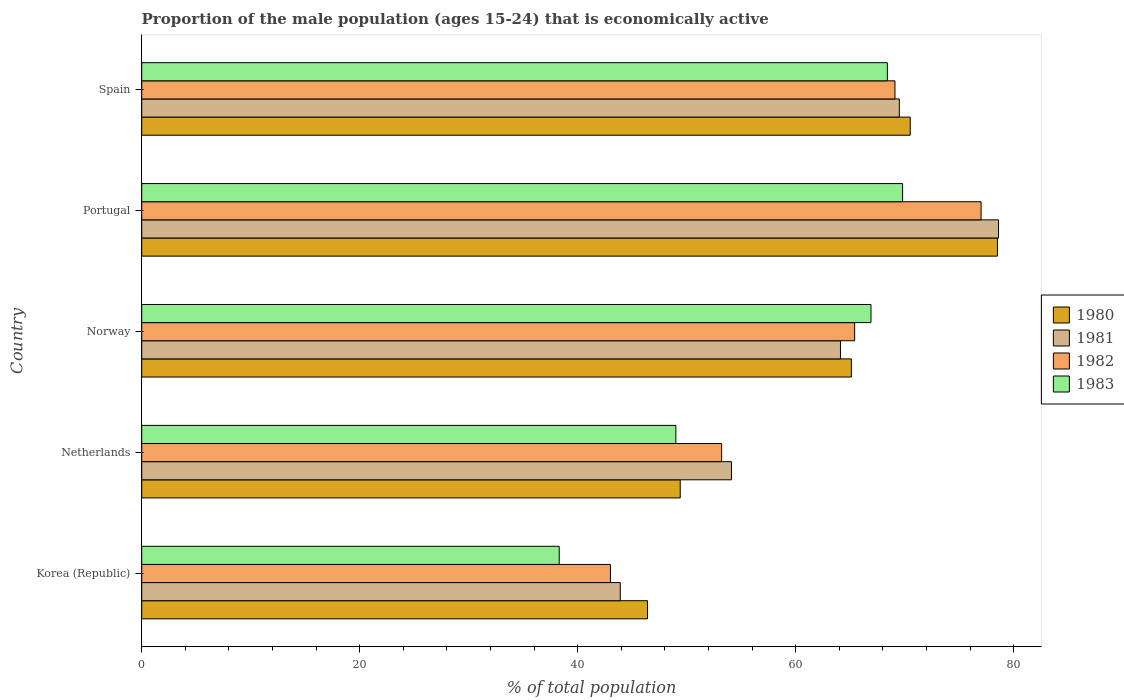How many groups of bars are there?
Give a very brief answer. 5. Are the number of bars on each tick of the Y-axis equal?
Give a very brief answer. Yes. How many bars are there on the 2nd tick from the top?
Your response must be concise. 4. In how many cases, is the number of bars for a given country not equal to the number of legend labels?
Provide a short and direct response. 0. What is the proportion of the male population that is economically active in 1983 in Norway?
Give a very brief answer. 66.9. Across all countries, what is the maximum proportion of the male population that is economically active in 1983?
Give a very brief answer. 69.8. In which country was the proportion of the male population that is economically active in 1982 minimum?
Offer a very short reply. Korea (Republic). What is the total proportion of the male population that is economically active in 1982 in the graph?
Your response must be concise. 307.7. What is the difference between the proportion of the male population that is economically active in 1982 in Portugal and that in Spain?
Keep it short and to the point. 7.9. What is the average proportion of the male population that is economically active in 1983 per country?
Make the answer very short. 58.48. What is the difference between the proportion of the male population that is economically active in 1983 and proportion of the male population that is economically active in 1982 in Korea (Republic)?
Your answer should be compact. -4.7. What is the ratio of the proportion of the male population that is economically active in 1980 in Netherlands to that in Norway?
Offer a terse response. 0.76. Is the difference between the proportion of the male population that is economically active in 1983 in Norway and Spain greater than the difference between the proportion of the male population that is economically active in 1982 in Norway and Spain?
Ensure brevity in your answer.  Yes. What is the difference between the highest and the second highest proportion of the male population that is economically active in 1983?
Your answer should be very brief. 1.4. What is the difference between the highest and the lowest proportion of the male population that is economically active in 1982?
Offer a very short reply. 34. In how many countries, is the proportion of the male population that is economically active in 1982 greater than the average proportion of the male population that is economically active in 1982 taken over all countries?
Offer a terse response. 3. Is the sum of the proportion of the male population that is economically active in 1980 in Korea (Republic) and Portugal greater than the maximum proportion of the male population that is economically active in 1983 across all countries?
Keep it short and to the point. Yes. Is it the case that in every country, the sum of the proportion of the male population that is economically active in 1980 and proportion of the male population that is economically active in 1982 is greater than the sum of proportion of the male population that is economically active in 1983 and proportion of the male population that is economically active in 1981?
Offer a terse response. No. What does the 3rd bar from the bottom in Spain represents?
Provide a short and direct response. 1982. Is it the case that in every country, the sum of the proportion of the male population that is economically active in 1983 and proportion of the male population that is economically active in 1982 is greater than the proportion of the male population that is economically active in 1980?
Ensure brevity in your answer.  Yes. Are all the bars in the graph horizontal?
Ensure brevity in your answer.  Yes. How many countries are there in the graph?
Provide a succinct answer. 5. What is the difference between two consecutive major ticks on the X-axis?
Your answer should be very brief. 20. Are the values on the major ticks of X-axis written in scientific E-notation?
Provide a short and direct response. No. Does the graph contain any zero values?
Give a very brief answer. No. Does the graph contain grids?
Give a very brief answer. No. How are the legend labels stacked?
Your answer should be compact. Vertical. What is the title of the graph?
Provide a short and direct response. Proportion of the male population (ages 15-24) that is economically active. What is the label or title of the X-axis?
Make the answer very short. % of total population. What is the % of total population in 1980 in Korea (Republic)?
Your answer should be compact. 46.4. What is the % of total population of 1981 in Korea (Republic)?
Offer a very short reply. 43.9. What is the % of total population of 1982 in Korea (Republic)?
Offer a terse response. 43. What is the % of total population in 1983 in Korea (Republic)?
Keep it short and to the point. 38.3. What is the % of total population in 1980 in Netherlands?
Your answer should be compact. 49.4. What is the % of total population of 1981 in Netherlands?
Make the answer very short. 54.1. What is the % of total population in 1982 in Netherlands?
Ensure brevity in your answer.  53.2. What is the % of total population of 1983 in Netherlands?
Your response must be concise. 49. What is the % of total population in 1980 in Norway?
Ensure brevity in your answer.  65.1. What is the % of total population of 1981 in Norway?
Ensure brevity in your answer.  64.1. What is the % of total population in 1982 in Norway?
Make the answer very short. 65.4. What is the % of total population in 1983 in Norway?
Provide a short and direct response. 66.9. What is the % of total population of 1980 in Portugal?
Offer a terse response. 78.5. What is the % of total population of 1981 in Portugal?
Give a very brief answer. 78.6. What is the % of total population of 1983 in Portugal?
Ensure brevity in your answer.  69.8. What is the % of total population in 1980 in Spain?
Your response must be concise. 70.5. What is the % of total population in 1981 in Spain?
Keep it short and to the point. 69.5. What is the % of total population in 1982 in Spain?
Provide a short and direct response. 69.1. What is the % of total population of 1983 in Spain?
Keep it short and to the point. 68.4. Across all countries, what is the maximum % of total population in 1980?
Provide a short and direct response. 78.5. Across all countries, what is the maximum % of total population of 1981?
Ensure brevity in your answer.  78.6. Across all countries, what is the maximum % of total population in 1983?
Provide a short and direct response. 69.8. Across all countries, what is the minimum % of total population of 1980?
Offer a very short reply. 46.4. Across all countries, what is the minimum % of total population of 1981?
Keep it short and to the point. 43.9. Across all countries, what is the minimum % of total population in 1982?
Provide a succinct answer. 43. Across all countries, what is the minimum % of total population in 1983?
Your answer should be very brief. 38.3. What is the total % of total population of 1980 in the graph?
Provide a short and direct response. 309.9. What is the total % of total population in 1981 in the graph?
Your answer should be compact. 310.2. What is the total % of total population of 1982 in the graph?
Provide a succinct answer. 307.7. What is the total % of total population in 1983 in the graph?
Provide a short and direct response. 292.4. What is the difference between the % of total population of 1980 in Korea (Republic) and that in Netherlands?
Give a very brief answer. -3. What is the difference between the % of total population of 1983 in Korea (Republic) and that in Netherlands?
Ensure brevity in your answer.  -10.7. What is the difference between the % of total population of 1980 in Korea (Republic) and that in Norway?
Give a very brief answer. -18.7. What is the difference between the % of total population of 1981 in Korea (Republic) and that in Norway?
Keep it short and to the point. -20.2. What is the difference between the % of total population of 1982 in Korea (Republic) and that in Norway?
Provide a succinct answer. -22.4. What is the difference between the % of total population of 1983 in Korea (Republic) and that in Norway?
Make the answer very short. -28.6. What is the difference between the % of total population in 1980 in Korea (Republic) and that in Portugal?
Give a very brief answer. -32.1. What is the difference between the % of total population of 1981 in Korea (Republic) and that in Portugal?
Provide a succinct answer. -34.7. What is the difference between the % of total population in 1982 in Korea (Republic) and that in Portugal?
Ensure brevity in your answer.  -34. What is the difference between the % of total population of 1983 in Korea (Republic) and that in Portugal?
Make the answer very short. -31.5. What is the difference between the % of total population of 1980 in Korea (Republic) and that in Spain?
Keep it short and to the point. -24.1. What is the difference between the % of total population in 1981 in Korea (Republic) and that in Spain?
Provide a short and direct response. -25.6. What is the difference between the % of total population of 1982 in Korea (Republic) and that in Spain?
Provide a short and direct response. -26.1. What is the difference between the % of total population of 1983 in Korea (Republic) and that in Spain?
Provide a succinct answer. -30.1. What is the difference between the % of total population of 1980 in Netherlands and that in Norway?
Give a very brief answer. -15.7. What is the difference between the % of total population in 1981 in Netherlands and that in Norway?
Ensure brevity in your answer.  -10. What is the difference between the % of total population in 1983 in Netherlands and that in Norway?
Ensure brevity in your answer.  -17.9. What is the difference between the % of total population in 1980 in Netherlands and that in Portugal?
Your response must be concise. -29.1. What is the difference between the % of total population in 1981 in Netherlands and that in Portugal?
Your answer should be compact. -24.5. What is the difference between the % of total population in 1982 in Netherlands and that in Portugal?
Your answer should be compact. -23.8. What is the difference between the % of total population of 1983 in Netherlands and that in Portugal?
Your answer should be compact. -20.8. What is the difference between the % of total population in 1980 in Netherlands and that in Spain?
Keep it short and to the point. -21.1. What is the difference between the % of total population in 1981 in Netherlands and that in Spain?
Make the answer very short. -15.4. What is the difference between the % of total population of 1982 in Netherlands and that in Spain?
Make the answer very short. -15.9. What is the difference between the % of total population in 1983 in Netherlands and that in Spain?
Provide a succinct answer. -19.4. What is the difference between the % of total population of 1980 in Norway and that in Portugal?
Make the answer very short. -13.4. What is the difference between the % of total population of 1981 in Norway and that in Portugal?
Provide a succinct answer. -14.5. What is the difference between the % of total population of 1982 in Norway and that in Portugal?
Offer a very short reply. -11.6. What is the difference between the % of total population of 1981 in Norway and that in Spain?
Your response must be concise. -5.4. What is the difference between the % of total population in 1983 in Norway and that in Spain?
Ensure brevity in your answer.  -1.5. What is the difference between the % of total population of 1983 in Portugal and that in Spain?
Ensure brevity in your answer.  1.4. What is the difference between the % of total population in 1980 in Korea (Republic) and the % of total population in 1981 in Netherlands?
Give a very brief answer. -7.7. What is the difference between the % of total population in 1981 in Korea (Republic) and the % of total population in 1982 in Netherlands?
Your response must be concise. -9.3. What is the difference between the % of total population in 1981 in Korea (Republic) and the % of total population in 1983 in Netherlands?
Offer a very short reply. -5.1. What is the difference between the % of total population in 1980 in Korea (Republic) and the % of total population in 1981 in Norway?
Provide a short and direct response. -17.7. What is the difference between the % of total population in 1980 in Korea (Republic) and the % of total population in 1983 in Norway?
Ensure brevity in your answer.  -20.5. What is the difference between the % of total population in 1981 in Korea (Republic) and the % of total population in 1982 in Norway?
Your answer should be very brief. -21.5. What is the difference between the % of total population of 1982 in Korea (Republic) and the % of total population of 1983 in Norway?
Ensure brevity in your answer.  -23.9. What is the difference between the % of total population in 1980 in Korea (Republic) and the % of total population in 1981 in Portugal?
Provide a succinct answer. -32.2. What is the difference between the % of total population of 1980 in Korea (Republic) and the % of total population of 1982 in Portugal?
Offer a terse response. -30.6. What is the difference between the % of total population of 1980 in Korea (Republic) and the % of total population of 1983 in Portugal?
Your answer should be compact. -23.4. What is the difference between the % of total population of 1981 in Korea (Republic) and the % of total population of 1982 in Portugal?
Keep it short and to the point. -33.1. What is the difference between the % of total population of 1981 in Korea (Republic) and the % of total population of 1983 in Portugal?
Provide a succinct answer. -25.9. What is the difference between the % of total population in 1982 in Korea (Republic) and the % of total population in 1983 in Portugal?
Make the answer very short. -26.8. What is the difference between the % of total population in 1980 in Korea (Republic) and the % of total population in 1981 in Spain?
Provide a succinct answer. -23.1. What is the difference between the % of total population in 1980 in Korea (Republic) and the % of total population in 1982 in Spain?
Provide a succinct answer. -22.7. What is the difference between the % of total population of 1980 in Korea (Republic) and the % of total population of 1983 in Spain?
Your response must be concise. -22. What is the difference between the % of total population in 1981 in Korea (Republic) and the % of total population in 1982 in Spain?
Keep it short and to the point. -25.2. What is the difference between the % of total population in 1981 in Korea (Republic) and the % of total population in 1983 in Spain?
Keep it short and to the point. -24.5. What is the difference between the % of total population of 1982 in Korea (Republic) and the % of total population of 1983 in Spain?
Offer a terse response. -25.4. What is the difference between the % of total population of 1980 in Netherlands and the % of total population of 1981 in Norway?
Your answer should be very brief. -14.7. What is the difference between the % of total population in 1980 in Netherlands and the % of total population in 1983 in Norway?
Offer a terse response. -17.5. What is the difference between the % of total population in 1981 in Netherlands and the % of total population in 1982 in Norway?
Keep it short and to the point. -11.3. What is the difference between the % of total population in 1982 in Netherlands and the % of total population in 1983 in Norway?
Provide a succinct answer. -13.7. What is the difference between the % of total population of 1980 in Netherlands and the % of total population of 1981 in Portugal?
Make the answer very short. -29.2. What is the difference between the % of total population of 1980 in Netherlands and the % of total population of 1982 in Portugal?
Offer a very short reply. -27.6. What is the difference between the % of total population of 1980 in Netherlands and the % of total population of 1983 in Portugal?
Offer a terse response. -20.4. What is the difference between the % of total population in 1981 in Netherlands and the % of total population in 1982 in Portugal?
Make the answer very short. -22.9. What is the difference between the % of total population of 1981 in Netherlands and the % of total population of 1983 in Portugal?
Your answer should be compact. -15.7. What is the difference between the % of total population in 1982 in Netherlands and the % of total population in 1983 in Portugal?
Provide a succinct answer. -16.6. What is the difference between the % of total population in 1980 in Netherlands and the % of total population in 1981 in Spain?
Your response must be concise. -20.1. What is the difference between the % of total population of 1980 in Netherlands and the % of total population of 1982 in Spain?
Keep it short and to the point. -19.7. What is the difference between the % of total population in 1980 in Netherlands and the % of total population in 1983 in Spain?
Make the answer very short. -19. What is the difference between the % of total population of 1981 in Netherlands and the % of total population of 1983 in Spain?
Make the answer very short. -14.3. What is the difference between the % of total population in 1982 in Netherlands and the % of total population in 1983 in Spain?
Offer a very short reply. -15.2. What is the difference between the % of total population in 1980 in Norway and the % of total population in 1981 in Portugal?
Give a very brief answer. -13.5. What is the difference between the % of total population of 1981 in Norway and the % of total population of 1982 in Portugal?
Offer a terse response. -12.9. What is the difference between the % of total population of 1981 in Norway and the % of total population of 1983 in Portugal?
Provide a succinct answer. -5.7. What is the difference between the % of total population in 1980 in Norway and the % of total population in 1983 in Spain?
Your response must be concise. -3.3. What is the difference between the % of total population of 1981 in Norway and the % of total population of 1983 in Spain?
Keep it short and to the point. -4.3. What is the difference between the % of total population of 1980 in Portugal and the % of total population of 1983 in Spain?
Give a very brief answer. 10.1. What is the difference between the % of total population in 1981 in Portugal and the % of total population in 1982 in Spain?
Keep it short and to the point. 9.5. What is the difference between the % of total population of 1981 in Portugal and the % of total population of 1983 in Spain?
Give a very brief answer. 10.2. What is the difference between the % of total population in 1982 in Portugal and the % of total population in 1983 in Spain?
Ensure brevity in your answer.  8.6. What is the average % of total population in 1980 per country?
Offer a very short reply. 61.98. What is the average % of total population of 1981 per country?
Your answer should be very brief. 62.04. What is the average % of total population of 1982 per country?
Offer a very short reply. 61.54. What is the average % of total population of 1983 per country?
Give a very brief answer. 58.48. What is the difference between the % of total population in 1982 and % of total population in 1983 in Korea (Republic)?
Provide a short and direct response. 4.7. What is the difference between the % of total population of 1980 and % of total population of 1981 in Netherlands?
Make the answer very short. -4.7. What is the difference between the % of total population of 1980 and % of total population of 1982 in Netherlands?
Keep it short and to the point. -3.8. What is the difference between the % of total population of 1980 and % of total population of 1983 in Norway?
Your answer should be compact. -1.8. What is the difference between the % of total population in 1982 and % of total population in 1983 in Norway?
Give a very brief answer. -1.5. What is the difference between the % of total population of 1980 and % of total population of 1982 in Portugal?
Your answer should be compact. 1.5. What is the difference between the % of total population in 1980 and % of total population in 1983 in Portugal?
Your response must be concise. 8.7. What is the difference between the % of total population of 1982 and % of total population of 1983 in Portugal?
Offer a terse response. 7.2. What is the difference between the % of total population of 1980 and % of total population of 1981 in Spain?
Your response must be concise. 1. What is the difference between the % of total population of 1981 and % of total population of 1982 in Spain?
Ensure brevity in your answer.  0.4. What is the difference between the % of total population in 1982 and % of total population in 1983 in Spain?
Your answer should be very brief. 0.7. What is the ratio of the % of total population in 1980 in Korea (Republic) to that in Netherlands?
Your answer should be compact. 0.94. What is the ratio of the % of total population of 1981 in Korea (Republic) to that in Netherlands?
Provide a succinct answer. 0.81. What is the ratio of the % of total population in 1982 in Korea (Republic) to that in Netherlands?
Make the answer very short. 0.81. What is the ratio of the % of total population in 1983 in Korea (Republic) to that in Netherlands?
Offer a terse response. 0.78. What is the ratio of the % of total population in 1980 in Korea (Republic) to that in Norway?
Provide a succinct answer. 0.71. What is the ratio of the % of total population of 1981 in Korea (Republic) to that in Norway?
Keep it short and to the point. 0.68. What is the ratio of the % of total population in 1982 in Korea (Republic) to that in Norway?
Provide a succinct answer. 0.66. What is the ratio of the % of total population in 1983 in Korea (Republic) to that in Norway?
Offer a very short reply. 0.57. What is the ratio of the % of total population of 1980 in Korea (Republic) to that in Portugal?
Keep it short and to the point. 0.59. What is the ratio of the % of total population of 1981 in Korea (Republic) to that in Portugal?
Provide a succinct answer. 0.56. What is the ratio of the % of total population of 1982 in Korea (Republic) to that in Portugal?
Provide a short and direct response. 0.56. What is the ratio of the % of total population of 1983 in Korea (Republic) to that in Portugal?
Offer a very short reply. 0.55. What is the ratio of the % of total population in 1980 in Korea (Republic) to that in Spain?
Provide a short and direct response. 0.66. What is the ratio of the % of total population in 1981 in Korea (Republic) to that in Spain?
Your response must be concise. 0.63. What is the ratio of the % of total population in 1982 in Korea (Republic) to that in Spain?
Give a very brief answer. 0.62. What is the ratio of the % of total population in 1983 in Korea (Republic) to that in Spain?
Ensure brevity in your answer.  0.56. What is the ratio of the % of total population in 1980 in Netherlands to that in Norway?
Ensure brevity in your answer.  0.76. What is the ratio of the % of total population of 1981 in Netherlands to that in Norway?
Make the answer very short. 0.84. What is the ratio of the % of total population in 1982 in Netherlands to that in Norway?
Your response must be concise. 0.81. What is the ratio of the % of total population of 1983 in Netherlands to that in Norway?
Your response must be concise. 0.73. What is the ratio of the % of total population of 1980 in Netherlands to that in Portugal?
Provide a succinct answer. 0.63. What is the ratio of the % of total population in 1981 in Netherlands to that in Portugal?
Your answer should be very brief. 0.69. What is the ratio of the % of total population of 1982 in Netherlands to that in Portugal?
Your answer should be very brief. 0.69. What is the ratio of the % of total population in 1983 in Netherlands to that in Portugal?
Make the answer very short. 0.7. What is the ratio of the % of total population of 1980 in Netherlands to that in Spain?
Your answer should be compact. 0.7. What is the ratio of the % of total population in 1981 in Netherlands to that in Spain?
Your answer should be compact. 0.78. What is the ratio of the % of total population in 1982 in Netherlands to that in Spain?
Offer a very short reply. 0.77. What is the ratio of the % of total population of 1983 in Netherlands to that in Spain?
Your answer should be very brief. 0.72. What is the ratio of the % of total population in 1980 in Norway to that in Portugal?
Provide a short and direct response. 0.83. What is the ratio of the % of total population in 1981 in Norway to that in Portugal?
Your answer should be compact. 0.82. What is the ratio of the % of total population of 1982 in Norway to that in Portugal?
Offer a very short reply. 0.85. What is the ratio of the % of total population in 1983 in Norway to that in Portugal?
Offer a terse response. 0.96. What is the ratio of the % of total population in 1980 in Norway to that in Spain?
Provide a succinct answer. 0.92. What is the ratio of the % of total population in 1981 in Norway to that in Spain?
Offer a very short reply. 0.92. What is the ratio of the % of total population in 1982 in Norway to that in Spain?
Your answer should be compact. 0.95. What is the ratio of the % of total population of 1983 in Norway to that in Spain?
Keep it short and to the point. 0.98. What is the ratio of the % of total population of 1980 in Portugal to that in Spain?
Provide a succinct answer. 1.11. What is the ratio of the % of total population in 1981 in Portugal to that in Spain?
Give a very brief answer. 1.13. What is the ratio of the % of total population of 1982 in Portugal to that in Spain?
Your answer should be very brief. 1.11. What is the ratio of the % of total population of 1983 in Portugal to that in Spain?
Provide a short and direct response. 1.02. What is the difference between the highest and the second highest % of total population in 1980?
Keep it short and to the point. 8. What is the difference between the highest and the second highest % of total population in 1981?
Make the answer very short. 9.1. What is the difference between the highest and the second highest % of total population in 1982?
Give a very brief answer. 7.9. What is the difference between the highest and the second highest % of total population in 1983?
Offer a very short reply. 1.4. What is the difference between the highest and the lowest % of total population of 1980?
Offer a very short reply. 32.1. What is the difference between the highest and the lowest % of total population in 1981?
Your answer should be very brief. 34.7. What is the difference between the highest and the lowest % of total population in 1982?
Provide a short and direct response. 34. What is the difference between the highest and the lowest % of total population of 1983?
Offer a very short reply. 31.5. 